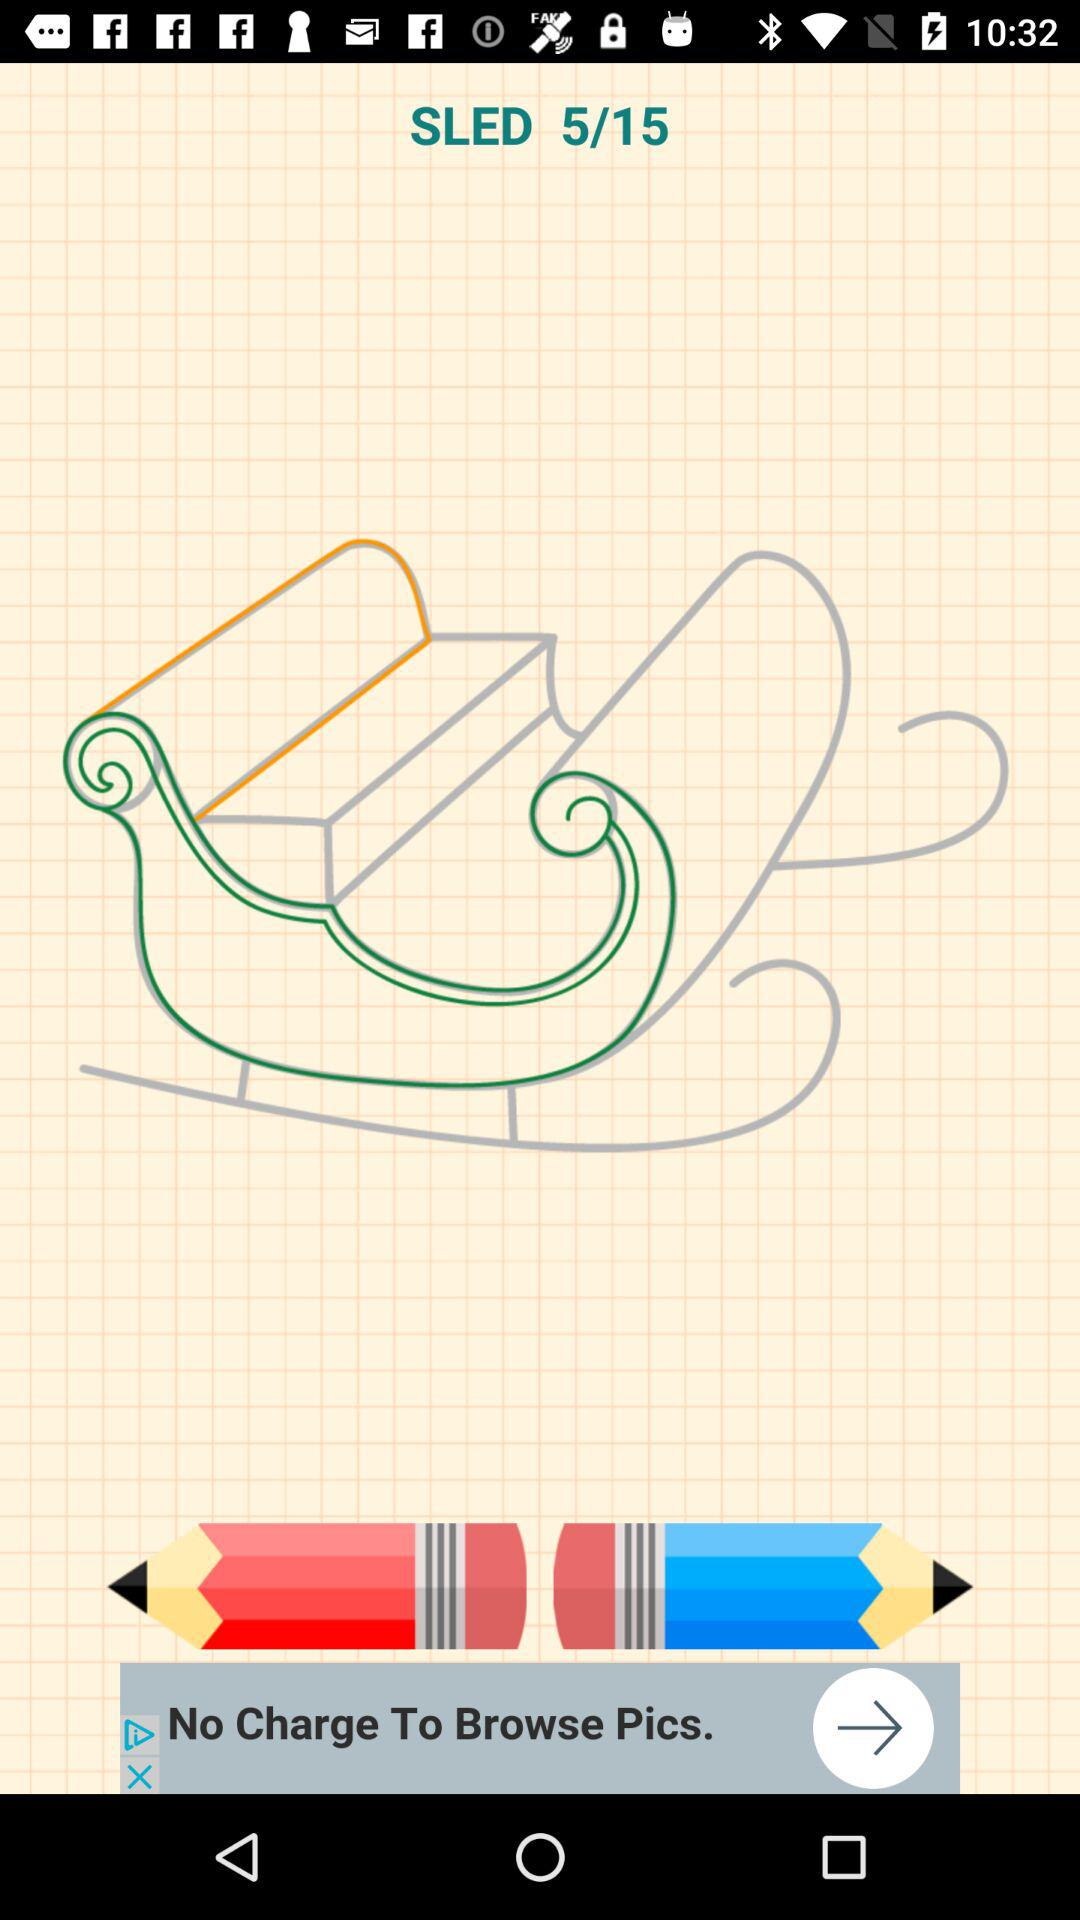What is the name of the application?
When the provided information is insufficient, respond with <no answer>. <no answer> 